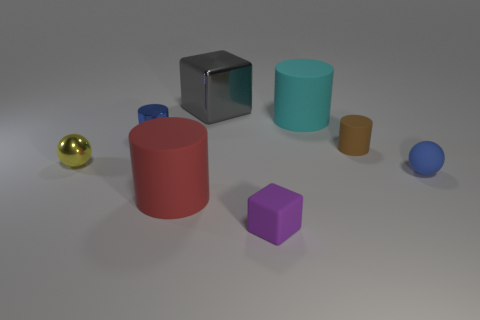Subtract all matte cylinders. How many cylinders are left? 1 Add 2 small cylinders. How many objects exist? 10 Subtract all blue balls. How many balls are left? 1 Subtract all spheres. How many objects are left? 6 Subtract 4 cylinders. How many cylinders are left? 0 Add 1 tiny matte objects. How many tiny matte objects exist? 4 Subtract 1 cyan cylinders. How many objects are left? 7 Subtract all gray balls. Subtract all red blocks. How many balls are left? 2 Subtract all tiny blue shiny balls. Subtract all matte objects. How many objects are left? 3 Add 5 metal cubes. How many metal cubes are left? 6 